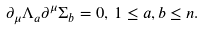Convert formula to latex. <formula><loc_0><loc_0><loc_500><loc_500>\partial _ { \mu } \Lambda _ { a } \partial ^ { \mu } \Sigma _ { b } = 0 , \, 1 \leq a , b \leq n .</formula> 